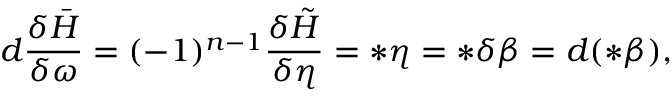Convert formula to latex. <formula><loc_0><loc_0><loc_500><loc_500>d \frac { \delta \bar { H } } { \delta \omega } = ( - 1 ) ^ { n - 1 } \frac { \delta \tilde { H } } { \delta \eta } = \ast \eta = \ast \delta \beta = d ( \ast \beta ) ,</formula> 